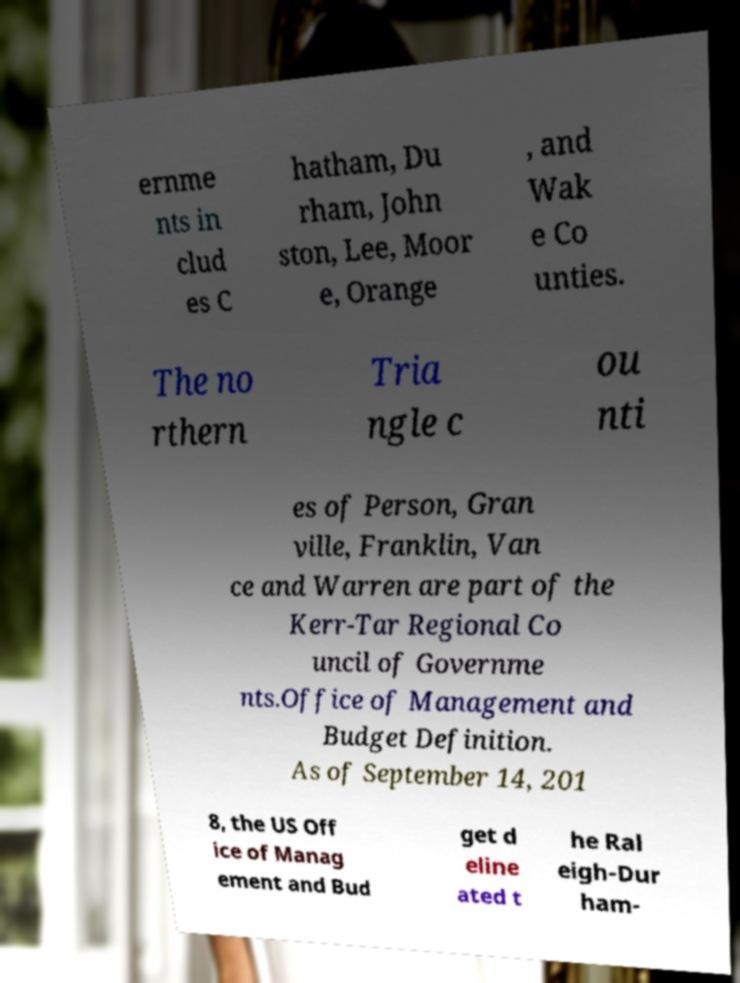Please identify and transcribe the text found in this image. ernme nts in clud es C hatham, Du rham, John ston, Lee, Moor e, Orange , and Wak e Co unties. The no rthern Tria ngle c ou nti es of Person, Gran ville, Franklin, Van ce and Warren are part of the Kerr-Tar Regional Co uncil of Governme nts.Office of Management and Budget Definition. As of September 14, 201 8, the US Off ice of Manag ement and Bud get d eline ated t he Ral eigh-Dur ham- 